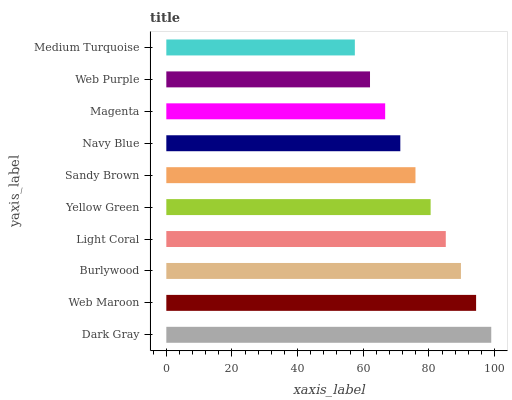Is Medium Turquoise the minimum?
Answer yes or no. Yes. Is Dark Gray the maximum?
Answer yes or no. Yes. Is Web Maroon the minimum?
Answer yes or no. No. Is Web Maroon the maximum?
Answer yes or no. No. Is Dark Gray greater than Web Maroon?
Answer yes or no. Yes. Is Web Maroon less than Dark Gray?
Answer yes or no. Yes. Is Web Maroon greater than Dark Gray?
Answer yes or no. No. Is Dark Gray less than Web Maroon?
Answer yes or no. No. Is Yellow Green the high median?
Answer yes or no. Yes. Is Sandy Brown the low median?
Answer yes or no. Yes. Is Web Purple the high median?
Answer yes or no. No. Is Dark Gray the low median?
Answer yes or no. No. 